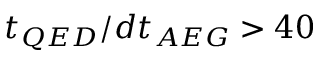Convert formula to latex. <formula><loc_0><loc_0><loc_500><loc_500>t _ { Q E D } / d t _ { A E G } > 4 0</formula> 